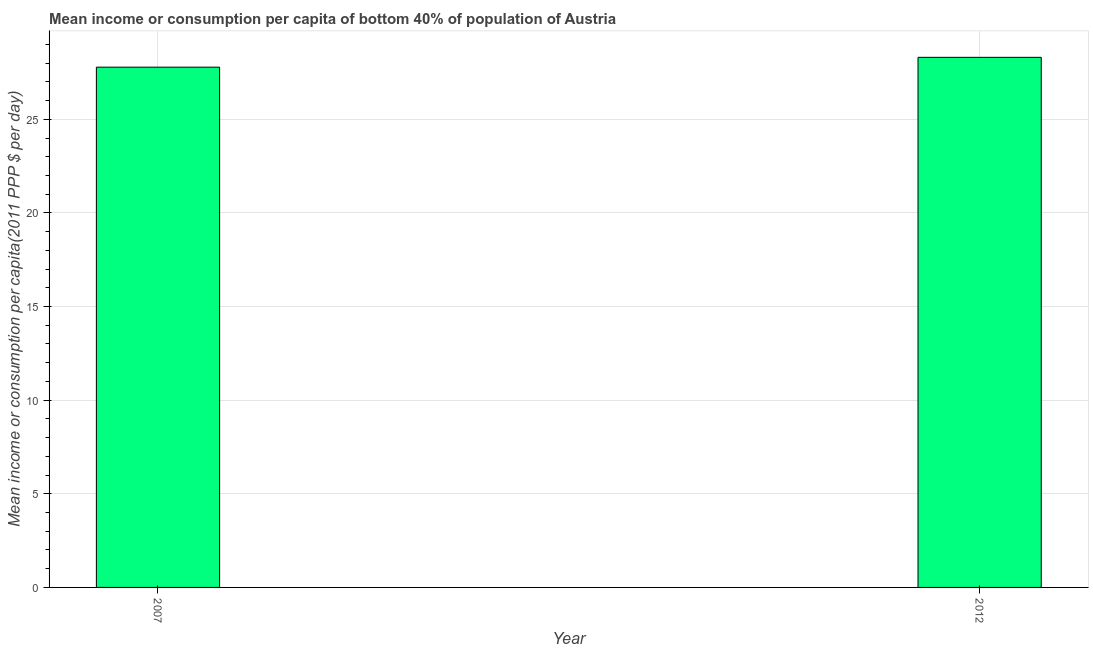What is the title of the graph?
Provide a short and direct response. Mean income or consumption per capita of bottom 40% of population of Austria. What is the label or title of the Y-axis?
Offer a terse response. Mean income or consumption per capita(2011 PPP $ per day). What is the mean income or consumption in 2012?
Ensure brevity in your answer.  28.31. Across all years, what is the maximum mean income or consumption?
Provide a short and direct response. 28.31. Across all years, what is the minimum mean income or consumption?
Offer a terse response. 27.78. In which year was the mean income or consumption minimum?
Keep it short and to the point. 2007. What is the sum of the mean income or consumption?
Provide a succinct answer. 56.09. What is the difference between the mean income or consumption in 2007 and 2012?
Your response must be concise. -0.53. What is the average mean income or consumption per year?
Offer a terse response. 28.05. What is the median mean income or consumption?
Offer a terse response. 28.05. In how many years, is the mean income or consumption greater than 7 $?
Ensure brevity in your answer.  2. What is the ratio of the mean income or consumption in 2007 to that in 2012?
Give a very brief answer. 0.98. Is the mean income or consumption in 2007 less than that in 2012?
Provide a short and direct response. Yes. How many bars are there?
Provide a succinct answer. 2. Are the values on the major ticks of Y-axis written in scientific E-notation?
Your response must be concise. No. What is the Mean income or consumption per capita(2011 PPP $ per day) of 2007?
Keep it short and to the point. 27.78. What is the Mean income or consumption per capita(2011 PPP $ per day) in 2012?
Keep it short and to the point. 28.31. What is the difference between the Mean income or consumption per capita(2011 PPP $ per day) in 2007 and 2012?
Provide a short and direct response. -0.52. What is the ratio of the Mean income or consumption per capita(2011 PPP $ per day) in 2007 to that in 2012?
Provide a succinct answer. 0.98. 